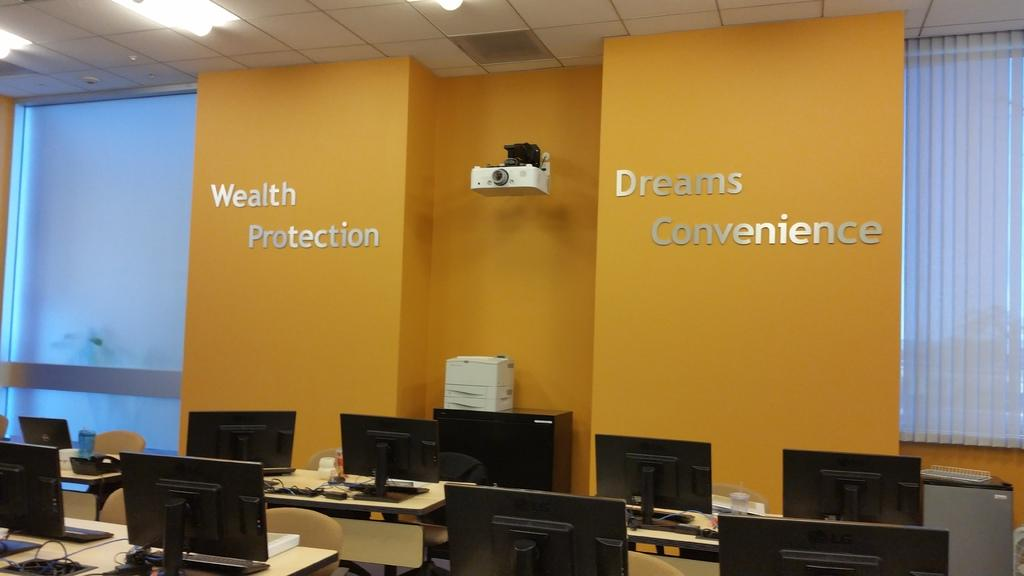What type of electronic devices can be seen in the image? There are monitors in the image. What else is present in the image that might be related to the monitors? There are cables and a projector visible in the image. What type of furniture is present in the image? There are objects on tables in the image. What can be seen on the walls in the image? There is a wall in the image. Are there any openings in the wall? Yes, there are windows in the image. What is visible at the top of the image? There are lights visible at the top of the image. What advertisement can be seen on the wall in the image? There is no advertisement present on the wall in the image. What rule is being enforced by the objects on the tables in the image? There is no rule being enforced by the objects on the tables in the image. 